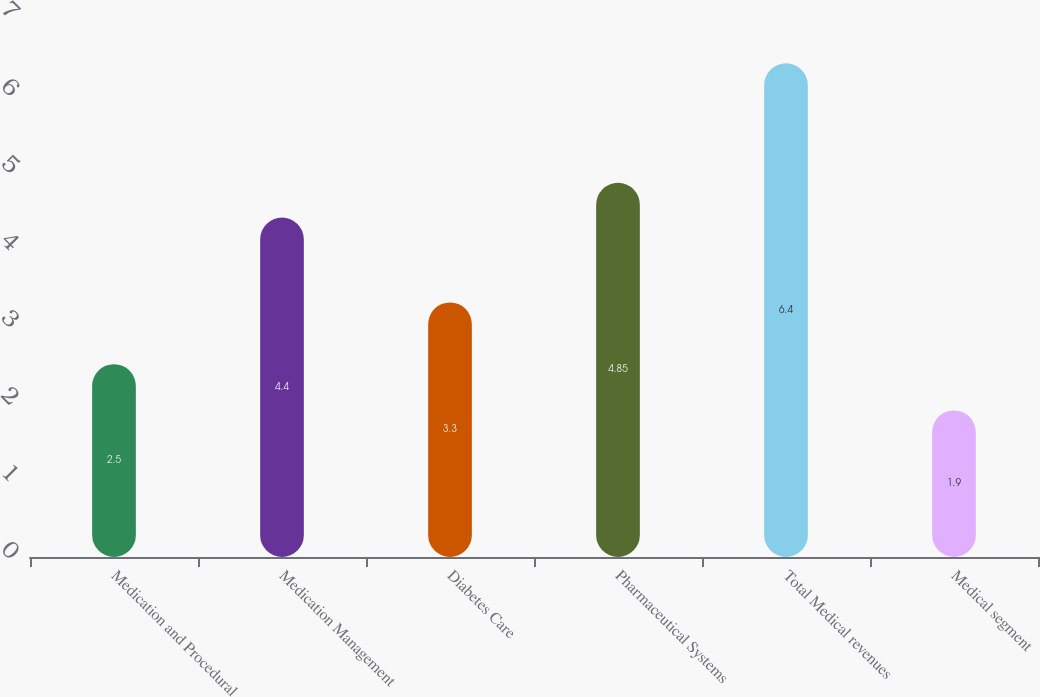<chart> <loc_0><loc_0><loc_500><loc_500><bar_chart><fcel>Medication and Procedural<fcel>Medication Management<fcel>Diabetes Care<fcel>Pharmaceutical Systems<fcel>Total Medical revenues<fcel>Medical segment<nl><fcel>2.5<fcel>4.4<fcel>3.3<fcel>4.85<fcel>6.4<fcel>1.9<nl></chart> 